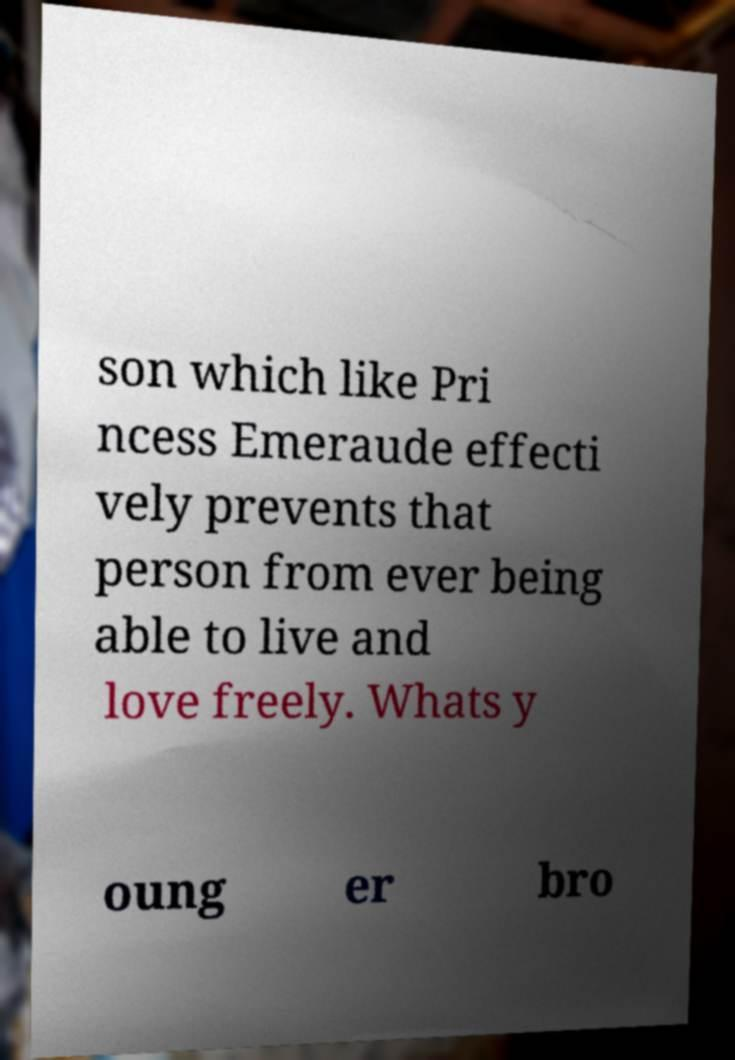Please read and relay the text visible in this image. What does it say? son which like Pri ncess Emeraude effecti vely prevents that person from ever being able to live and love freely. Whats y oung er bro 